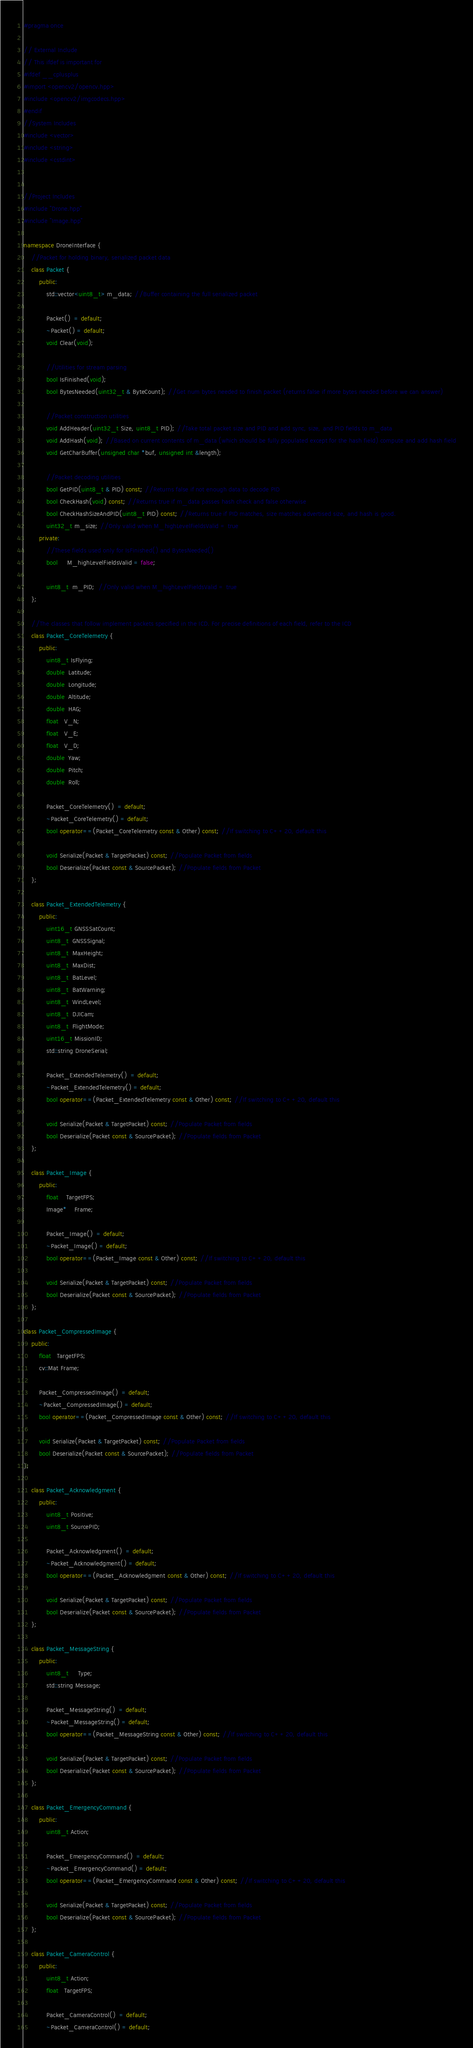Convert code to text. <code><loc_0><loc_0><loc_500><loc_500><_C++_>#pragma once

// External Include
// This ifdef is important for 
#ifdef __cplusplus
#import <opencv2/opencv.hpp>
#include <opencv2/imgcodecs.hpp>
#endif
//System Includes
#include <vector>
#include <string>
#include <cstdint>


//Project Includes
#include "Drone.hpp"
#include "Image.hpp"

namespace DroneInterface {
    //Packet for holding binary, serialized packet data
    class Packet {
        public:
            std::vector<uint8_t> m_data; //Buffer containing the full serialized packet
            
            Packet()  = default;
            ~Packet() = default;
            void Clear(void);
            
            //Utilities for stream parsing
            bool IsFinished(void);
            bool BytesNeeded(uint32_t & ByteCount); //Get num bytes needed to finish packet (returns false if more bytes needed before we can answer)
            
            //Packet construction utilities
            void AddHeader(uint32_t Size, uint8_t PID); //Take total packet size and PID and add sync, size, and PID fields to m_data
            void AddHash(void); //Based on current contents of m_data (which should be fully populated except for the hash field) compute and add hash field
            void GetCharBuffer(unsigned char *buf, unsigned int &length);
            
            //Packet decoding utilities
            bool GetPID(uint8_t & PID) const; //Returns false if not enough data to decode PID
            bool CheckHash(void) const; //Returns true if m_data passes hash check and false otherwise
            bool CheckHashSizeAndPID(uint8_t PID) const; //Returns true if PID matches, size matches advertised size, and hash is good.
            uint32_t m_size; //Only valid when M_highLevelFieldsValid = true
        private:
            //These fields used only for IsFinished() and BytesNeeded()
            bool     M_highLevelFieldsValid = false;
            
            uint8_t  m_PID;  //Only valid when M_highLevelFieldsValid = true
    };
    
    //The classes that follow implement packets specified in the ICD. For precise definitions of each field, refer to the ICD
    class Packet_CoreTelemetry {
        public:
            uint8_t IsFlying;
            double  Latitude;
            double  Longitude;
            double  Altitude;
            double  HAG;
            float   V_N;
            float   V_E;
            float   V_D;
            double  Yaw;
            double  Pitch;
            double  Roll;
            
            Packet_CoreTelemetry()  = default;
            ~Packet_CoreTelemetry() = default;
            bool operator==(Packet_CoreTelemetry const & Other) const; //If switching to C++20, default this
            
            void Serialize(Packet & TargetPacket) const; //Populate Packet from fields
            bool Deserialize(Packet const & SourcePacket); //Populate fields from Packet
    };

    class Packet_ExtendedTelemetry {
        public:
            uint16_t GNSSSatCount;
            uint8_t  GNSSSignal;
            uint8_t  MaxHeight;
            uint8_t  MaxDist;
            uint8_t  BatLevel;
            uint8_t  BatWarning;
            uint8_t  WindLevel;
            uint8_t  DJICam;
            uint8_t  FlightMode;
            uint16_t MissionID;
            std::string DroneSerial;
            
            Packet_ExtendedTelemetry()  = default;
            ~Packet_ExtendedTelemetry() = default;
            bool operator==(Packet_ExtendedTelemetry const & Other) const; //If switching to C++20, default this
            
            void Serialize(Packet & TargetPacket) const; //Populate Packet from fields
            bool Deserialize(Packet const & SourcePacket); //Populate fields from Packet
    };
    
    class Packet_Image {
        public:
            float    TargetFPS;
            Image*    Frame;
            
            Packet_Image()  = default;
            ~Packet_Image() = default;
            bool operator==(Packet_Image const & Other) const; //If switching to C++20, default this
            
            void Serialize(Packet & TargetPacket) const; //Populate Packet from fields
            bool Deserialize(Packet const & SourcePacket); //Populate fields from Packet
    };

class Packet_CompressedImage {
    public:
        float   TargetFPS;
        cv::Mat Frame;
        
        Packet_CompressedImage()  = default;
        ~Packet_CompressedImage() = default;
        bool operator==(Packet_CompressedImage const & Other) const; //If switching to C++20, default this
        
        void Serialize(Packet & TargetPacket) const; //Populate Packet from fields
        bool Deserialize(Packet const & SourcePacket); //Populate fields from Packet
};

    class Packet_Acknowledgment {
        public:
            uint8_t Positive;
            uint8_t SourcePID;
            
            Packet_Acknowledgment()  = default;
            ~Packet_Acknowledgment() = default;
            bool operator==(Packet_Acknowledgment const & Other) const; //If switching to C++20, default this
            
            void Serialize(Packet & TargetPacket) const; //Populate Packet from fields
            bool Deserialize(Packet const & SourcePacket); //Populate fields from Packet
    };

    class Packet_MessageString {
        public:
            uint8_t     Type;
            std::string Message;
            
            Packet_MessageString()  = default;
            ~Packet_MessageString() = default;
            bool operator==(Packet_MessageString const & Other) const; //If switching to C++20, default this
            
            void Serialize(Packet & TargetPacket) const; //Populate Packet from fields
            bool Deserialize(Packet const & SourcePacket); //Populate fields from Packet
    };

    class Packet_EmergencyCommand {
        public:
            uint8_t Action;
            
            Packet_EmergencyCommand()  = default;
            ~Packet_EmergencyCommand() = default;
            bool operator==(Packet_EmergencyCommand const & Other) const; //If switching to C++20, default this
            
            void Serialize(Packet & TargetPacket) const; //Populate Packet from fields
            bool Deserialize(Packet const & SourcePacket); //Populate fields from Packet
    };
    
    class Packet_CameraControl {
        public:
            uint8_t Action;
            float   TargetFPS;
            
            Packet_CameraControl()  = default;
            ~Packet_CameraControl() = default;</code> 